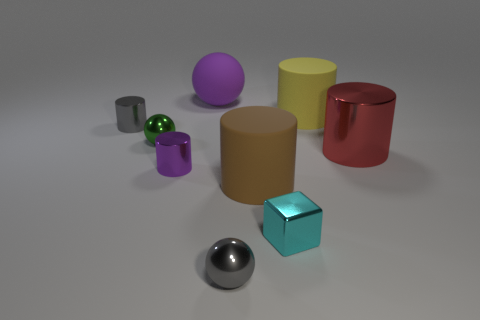There is a cylinder that is behind the gray object left of the tiny ball that is to the right of the tiny green metal thing; how big is it?
Offer a terse response. Large. There is a purple rubber object; is its shape the same as the tiny gray shiny object to the right of the gray shiny cylinder?
Your answer should be very brief. Yes. There is a gray object that is the same material as the gray cylinder; what size is it?
Your response must be concise. Small. Is there anything else of the same color as the large shiny thing?
Offer a terse response. No. There is a ball behind the gray metallic object that is on the left side of the ball on the right side of the big purple sphere; what is its material?
Ensure brevity in your answer.  Rubber. How many rubber things are tiny purple things or small spheres?
Your answer should be very brief. 0. What number of objects are red objects or gray objects that are to the left of the cyan metal object?
Provide a succinct answer. 3. There is a gray object that is behind the cyan shiny block; is it the same size as the yellow rubber thing?
Make the answer very short. No. How many other objects are there of the same shape as the big brown thing?
Ensure brevity in your answer.  4. How many purple objects are large metallic cylinders or metal spheres?
Ensure brevity in your answer.  0. 